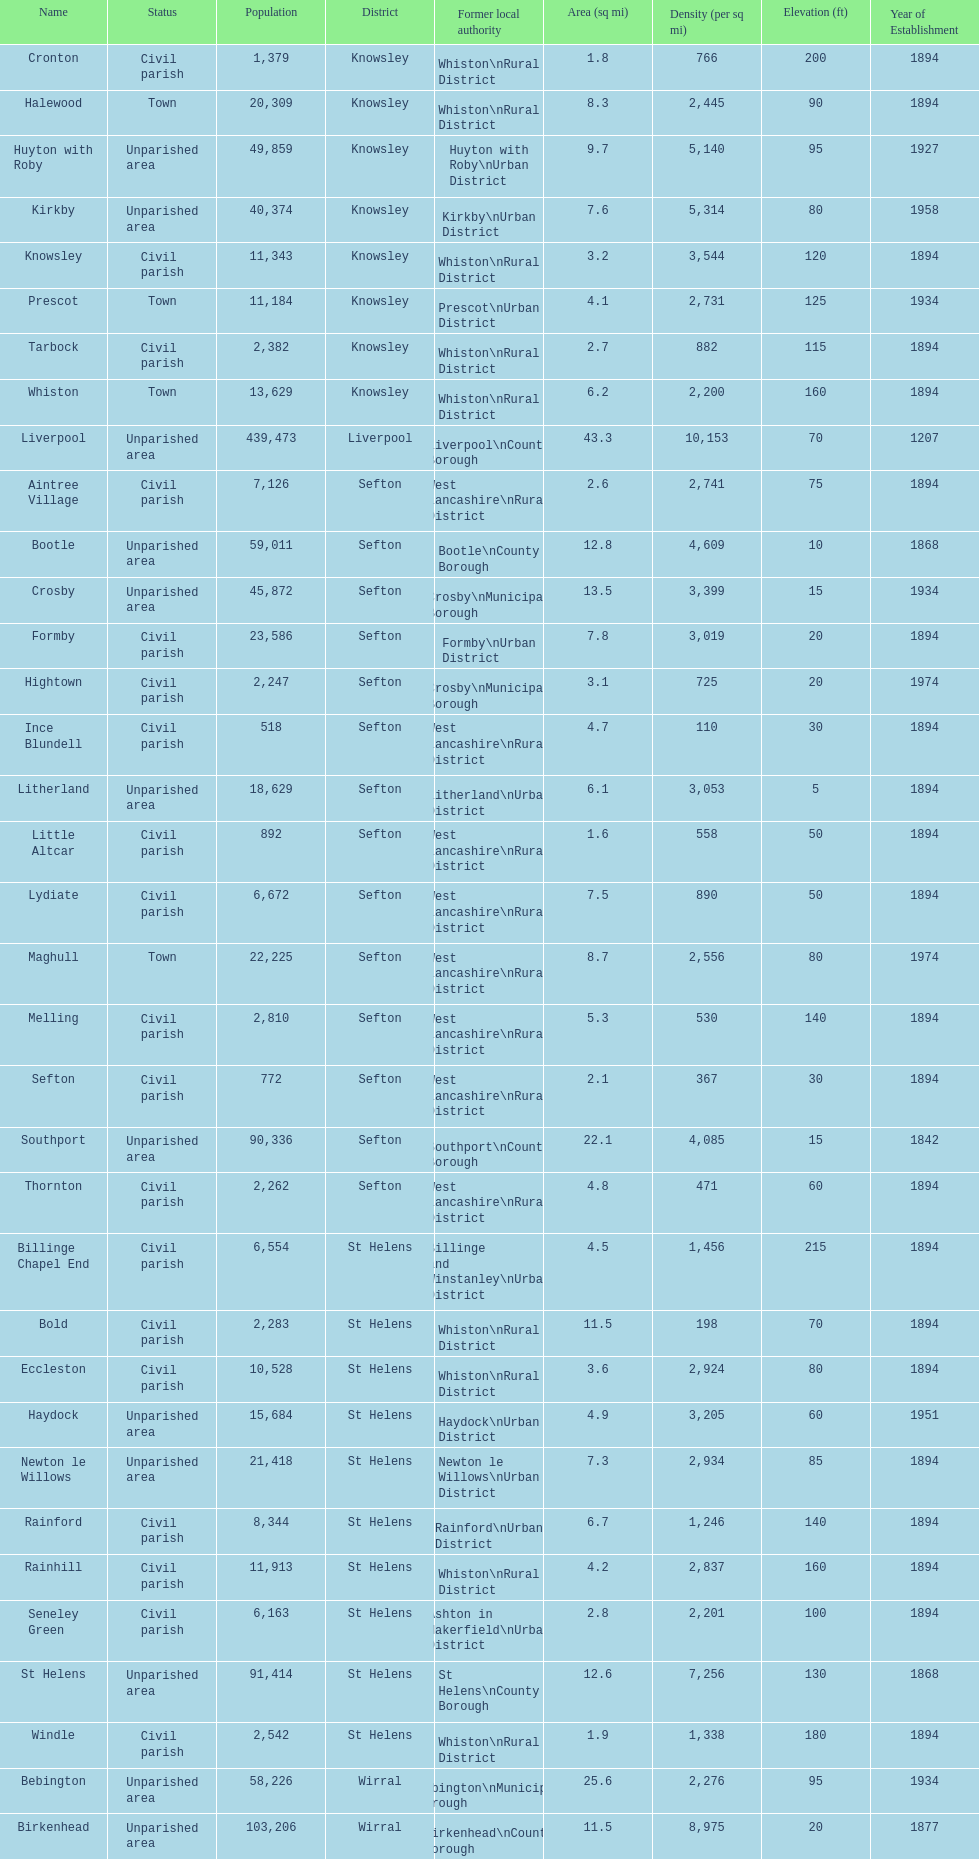What is the largest area in terms of population? Liverpool. 